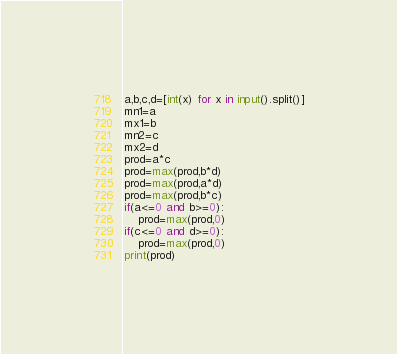Convert code to text. <code><loc_0><loc_0><loc_500><loc_500><_Python_>a,b,c,d=[int(x) for x in input().split()]
mn1=a
mx1=b
mn2=c
mx2=d
prod=a*c
prod=max(prod,b*d)
prod=max(prod,a*d)
prod=max(prod,b*c)
if(a<=0 and b>=0):
    prod=max(prod,0)
if(c<=0 and d>=0):
    prod=max(prod,0)
print(prod)
</code> 